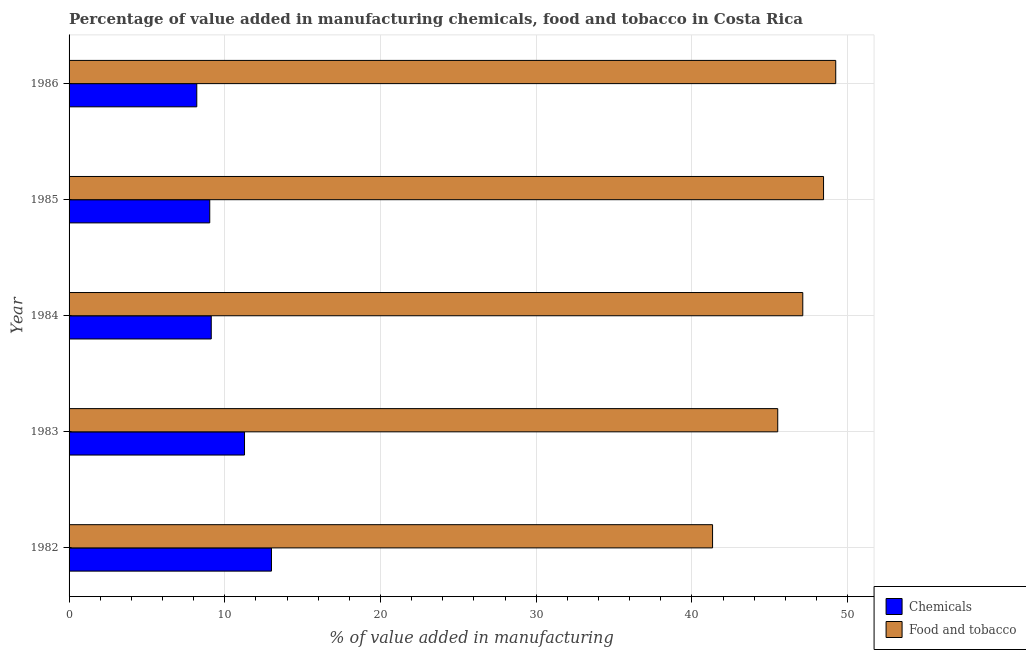How many different coloured bars are there?
Keep it short and to the point. 2. Are the number of bars on each tick of the Y-axis equal?
Ensure brevity in your answer.  Yes. What is the value added by manufacturing food and tobacco in 1985?
Ensure brevity in your answer.  48.46. Across all years, what is the maximum value added by  manufacturing chemicals?
Ensure brevity in your answer.  13. Across all years, what is the minimum value added by manufacturing food and tobacco?
Make the answer very short. 41.33. In which year was the value added by manufacturing food and tobacco maximum?
Your answer should be compact. 1986. In which year was the value added by  manufacturing chemicals minimum?
Keep it short and to the point. 1986. What is the total value added by manufacturing food and tobacco in the graph?
Give a very brief answer. 231.67. What is the difference between the value added by  manufacturing chemicals in 1983 and that in 1984?
Offer a terse response. 2.14. What is the difference between the value added by manufacturing food and tobacco in 1983 and the value added by  manufacturing chemicals in 1986?
Keep it short and to the point. 37.31. What is the average value added by manufacturing food and tobacco per year?
Give a very brief answer. 46.33. In the year 1986, what is the difference between the value added by  manufacturing chemicals and value added by manufacturing food and tobacco?
Your answer should be very brief. -41.04. In how many years, is the value added by  manufacturing chemicals greater than 18 %?
Provide a short and direct response. 0. What is the ratio of the value added by manufacturing food and tobacco in 1983 to that in 1986?
Keep it short and to the point. 0.92. Is the value added by  manufacturing chemicals in 1982 less than that in 1985?
Give a very brief answer. No. What is the difference between the highest and the second highest value added by manufacturing food and tobacco?
Your answer should be very brief. 0.78. Is the sum of the value added by manufacturing food and tobacco in 1982 and 1986 greater than the maximum value added by  manufacturing chemicals across all years?
Make the answer very short. Yes. What does the 1st bar from the top in 1985 represents?
Provide a succinct answer. Food and tobacco. What does the 1st bar from the bottom in 1983 represents?
Make the answer very short. Chemicals. How many years are there in the graph?
Your response must be concise. 5. What is the difference between two consecutive major ticks on the X-axis?
Offer a very short reply. 10. Are the values on the major ticks of X-axis written in scientific E-notation?
Your answer should be very brief. No. Does the graph contain any zero values?
Ensure brevity in your answer.  No. How are the legend labels stacked?
Keep it short and to the point. Vertical. What is the title of the graph?
Your answer should be very brief. Percentage of value added in manufacturing chemicals, food and tobacco in Costa Rica. What is the label or title of the X-axis?
Ensure brevity in your answer.  % of value added in manufacturing. What is the label or title of the Y-axis?
Keep it short and to the point. Year. What is the % of value added in manufacturing in Chemicals in 1982?
Offer a terse response. 13. What is the % of value added in manufacturing in Food and tobacco in 1982?
Give a very brief answer. 41.33. What is the % of value added in manufacturing in Chemicals in 1983?
Provide a succinct answer. 11.27. What is the % of value added in manufacturing in Food and tobacco in 1983?
Make the answer very short. 45.52. What is the % of value added in manufacturing of Chemicals in 1984?
Ensure brevity in your answer.  9.13. What is the % of value added in manufacturing of Food and tobacco in 1984?
Provide a short and direct response. 47.12. What is the % of value added in manufacturing in Chemicals in 1985?
Make the answer very short. 9.04. What is the % of value added in manufacturing of Food and tobacco in 1985?
Give a very brief answer. 48.46. What is the % of value added in manufacturing of Chemicals in 1986?
Your answer should be very brief. 8.2. What is the % of value added in manufacturing of Food and tobacco in 1986?
Your answer should be very brief. 49.24. Across all years, what is the maximum % of value added in manufacturing of Chemicals?
Your answer should be compact. 13. Across all years, what is the maximum % of value added in manufacturing in Food and tobacco?
Offer a terse response. 49.24. Across all years, what is the minimum % of value added in manufacturing in Chemicals?
Your answer should be very brief. 8.2. Across all years, what is the minimum % of value added in manufacturing in Food and tobacco?
Keep it short and to the point. 41.33. What is the total % of value added in manufacturing in Chemicals in the graph?
Provide a succinct answer. 50.64. What is the total % of value added in manufacturing in Food and tobacco in the graph?
Keep it short and to the point. 231.67. What is the difference between the % of value added in manufacturing in Chemicals in 1982 and that in 1983?
Provide a succinct answer. 1.73. What is the difference between the % of value added in manufacturing in Food and tobacco in 1982 and that in 1983?
Your response must be concise. -4.19. What is the difference between the % of value added in manufacturing of Chemicals in 1982 and that in 1984?
Provide a short and direct response. 3.87. What is the difference between the % of value added in manufacturing of Food and tobacco in 1982 and that in 1984?
Your answer should be very brief. -5.79. What is the difference between the % of value added in manufacturing in Chemicals in 1982 and that in 1985?
Your response must be concise. 3.96. What is the difference between the % of value added in manufacturing in Food and tobacco in 1982 and that in 1985?
Offer a terse response. -7.13. What is the difference between the % of value added in manufacturing of Chemicals in 1982 and that in 1986?
Give a very brief answer. 4.8. What is the difference between the % of value added in manufacturing in Food and tobacco in 1982 and that in 1986?
Your answer should be very brief. -7.91. What is the difference between the % of value added in manufacturing in Chemicals in 1983 and that in 1984?
Make the answer very short. 2.14. What is the difference between the % of value added in manufacturing of Food and tobacco in 1983 and that in 1984?
Offer a terse response. -1.61. What is the difference between the % of value added in manufacturing of Chemicals in 1983 and that in 1985?
Provide a short and direct response. 2.23. What is the difference between the % of value added in manufacturing in Food and tobacco in 1983 and that in 1985?
Your answer should be very brief. -2.94. What is the difference between the % of value added in manufacturing in Chemicals in 1983 and that in 1986?
Provide a short and direct response. 3.07. What is the difference between the % of value added in manufacturing of Food and tobacco in 1983 and that in 1986?
Ensure brevity in your answer.  -3.73. What is the difference between the % of value added in manufacturing in Chemicals in 1984 and that in 1985?
Your answer should be very brief. 0.1. What is the difference between the % of value added in manufacturing of Food and tobacco in 1984 and that in 1985?
Provide a short and direct response. -1.33. What is the difference between the % of value added in manufacturing of Chemicals in 1984 and that in 1986?
Provide a short and direct response. 0.93. What is the difference between the % of value added in manufacturing of Food and tobacco in 1984 and that in 1986?
Offer a very short reply. -2.12. What is the difference between the % of value added in manufacturing of Chemicals in 1985 and that in 1986?
Make the answer very short. 0.83. What is the difference between the % of value added in manufacturing in Food and tobacco in 1985 and that in 1986?
Offer a terse response. -0.78. What is the difference between the % of value added in manufacturing of Chemicals in 1982 and the % of value added in manufacturing of Food and tobacco in 1983?
Your answer should be very brief. -32.52. What is the difference between the % of value added in manufacturing of Chemicals in 1982 and the % of value added in manufacturing of Food and tobacco in 1984?
Make the answer very short. -34.13. What is the difference between the % of value added in manufacturing of Chemicals in 1982 and the % of value added in manufacturing of Food and tobacco in 1985?
Keep it short and to the point. -35.46. What is the difference between the % of value added in manufacturing of Chemicals in 1982 and the % of value added in manufacturing of Food and tobacco in 1986?
Your answer should be very brief. -36.24. What is the difference between the % of value added in manufacturing in Chemicals in 1983 and the % of value added in manufacturing in Food and tobacco in 1984?
Provide a short and direct response. -35.86. What is the difference between the % of value added in manufacturing of Chemicals in 1983 and the % of value added in manufacturing of Food and tobacco in 1985?
Keep it short and to the point. -37.19. What is the difference between the % of value added in manufacturing in Chemicals in 1983 and the % of value added in manufacturing in Food and tobacco in 1986?
Your answer should be compact. -37.97. What is the difference between the % of value added in manufacturing in Chemicals in 1984 and the % of value added in manufacturing in Food and tobacco in 1985?
Provide a succinct answer. -39.33. What is the difference between the % of value added in manufacturing of Chemicals in 1984 and the % of value added in manufacturing of Food and tobacco in 1986?
Offer a very short reply. -40.11. What is the difference between the % of value added in manufacturing of Chemicals in 1985 and the % of value added in manufacturing of Food and tobacco in 1986?
Give a very brief answer. -40.21. What is the average % of value added in manufacturing in Chemicals per year?
Your answer should be compact. 10.13. What is the average % of value added in manufacturing of Food and tobacco per year?
Your answer should be very brief. 46.33. In the year 1982, what is the difference between the % of value added in manufacturing in Chemicals and % of value added in manufacturing in Food and tobacco?
Make the answer very short. -28.33. In the year 1983, what is the difference between the % of value added in manufacturing of Chemicals and % of value added in manufacturing of Food and tobacco?
Provide a succinct answer. -34.25. In the year 1984, what is the difference between the % of value added in manufacturing of Chemicals and % of value added in manufacturing of Food and tobacco?
Offer a terse response. -37.99. In the year 1985, what is the difference between the % of value added in manufacturing of Chemicals and % of value added in manufacturing of Food and tobacco?
Make the answer very short. -39.42. In the year 1986, what is the difference between the % of value added in manufacturing of Chemicals and % of value added in manufacturing of Food and tobacco?
Give a very brief answer. -41.04. What is the ratio of the % of value added in manufacturing in Chemicals in 1982 to that in 1983?
Provide a short and direct response. 1.15. What is the ratio of the % of value added in manufacturing in Food and tobacco in 1982 to that in 1983?
Make the answer very short. 0.91. What is the ratio of the % of value added in manufacturing in Chemicals in 1982 to that in 1984?
Give a very brief answer. 1.42. What is the ratio of the % of value added in manufacturing of Food and tobacco in 1982 to that in 1984?
Provide a short and direct response. 0.88. What is the ratio of the % of value added in manufacturing in Chemicals in 1982 to that in 1985?
Offer a terse response. 1.44. What is the ratio of the % of value added in manufacturing of Food and tobacco in 1982 to that in 1985?
Provide a short and direct response. 0.85. What is the ratio of the % of value added in manufacturing in Chemicals in 1982 to that in 1986?
Your response must be concise. 1.58. What is the ratio of the % of value added in manufacturing in Food and tobacco in 1982 to that in 1986?
Your answer should be compact. 0.84. What is the ratio of the % of value added in manufacturing in Chemicals in 1983 to that in 1984?
Offer a very short reply. 1.23. What is the ratio of the % of value added in manufacturing of Food and tobacco in 1983 to that in 1984?
Ensure brevity in your answer.  0.97. What is the ratio of the % of value added in manufacturing of Chemicals in 1983 to that in 1985?
Your answer should be very brief. 1.25. What is the ratio of the % of value added in manufacturing of Food and tobacco in 1983 to that in 1985?
Make the answer very short. 0.94. What is the ratio of the % of value added in manufacturing of Chemicals in 1983 to that in 1986?
Your answer should be compact. 1.37. What is the ratio of the % of value added in manufacturing in Food and tobacco in 1983 to that in 1986?
Make the answer very short. 0.92. What is the ratio of the % of value added in manufacturing in Chemicals in 1984 to that in 1985?
Make the answer very short. 1.01. What is the ratio of the % of value added in manufacturing of Food and tobacco in 1984 to that in 1985?
Keep it short and to the point. 0.97. What is the ratio of the % of value added in manufacturing of Chemicals in 1984 to that in 1986?
Offer a very short reply. 1.11. What is the ratio of the % of value added in manufacturing in Food and tobacco in 1984 to that in 1986?
Provide a short and direct response. 0.96. What is the ratio of the % of value added in manufacturing in Chemicals in 1985 to that in 1986?
Make the answer very short. 1.1. What is the ratio of the % of value added in manufacturing of Food and tobacco in 1985 to that in 1986?
Your answer should be very brief. 0.98. What is the difference between the highest and the second highest % of value added in manufacturing in Chemicals?
Keep it short and to the point. 1.73. What is the difference between the highest and the second highest % of value added in manufacturing of Food and tobacco?
Make the answer very short. 0.78. What is the difference between the highest and the lowest % of value added in manufacturing in Chemicals?
Provide a short and direct response. 4.8. What is the difference between the highest and the lowest % of value added in manufacturing of Food and tobacco?
Offer a terse response. 7.91. 